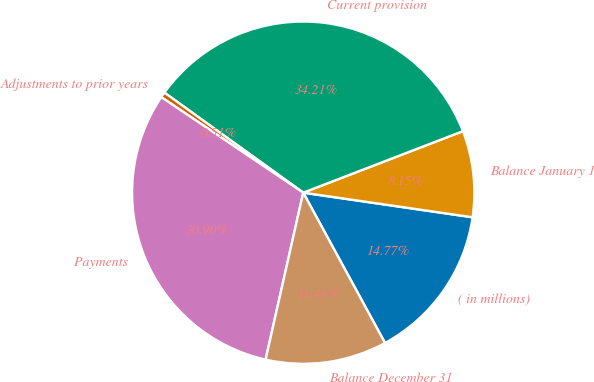Convert chart. <chart><loc_0><loc_0><loc_500><loc_500><pie_chart><fcel>( in millions)<fcel>Balance January 1<fcel>Current provision<fcel>Adjustments to prior years<fcel>Payments<fcel>Balance December 31<nl><fcel>14.77%<fcel>8.15%<fcel>34.21%<fcel>0.51%<fcel>30.9%<fcel>11.46%<nl></chart> 